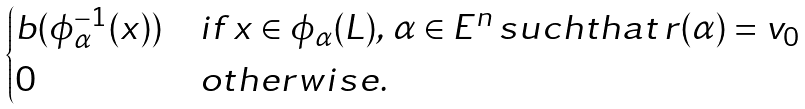Convert formula to latex. <formula><loc_0><loc_0><loc_500><loc_500>\begin{cases} b ( \phi _ { \alpha } ^ { - 1 } ( x ) ) & i f \, x \in \phi _ { \alpha } ( L ) , \, \alpha \in E ^ { n } \, s u c h t h a t \, r ( \alpha ) = v _ { 0 } \\ 0 & o t h e r w i s e . \end{cases}</formula> 